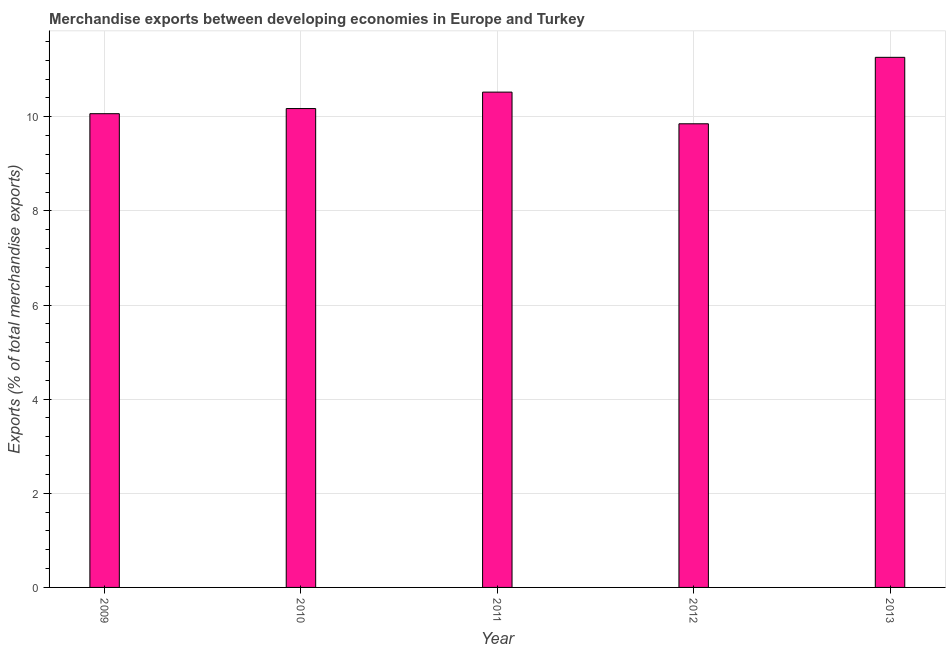Does the graph contain any zero values?
Your response must be concise. No. Does the graph contain grids?
Keep it short and to the point. Yes. What is the title of the graph?
Your answer should be compact. Merchandise exports between developing economies in Europe and Turkey. What is the label or title of the X-axis?
Provide a short and direct response. Year. What is the label or title of the Y-axis?
Your answer should be very brief. Exports (% of total merchandise exports). What is the merchandise exports in 2009?
Provide a short and direct response. 10.07. Across all years, what is the maximum merchandise exports?
Keep it short and to the point. 11.26. Across all years, what is the minimum merchandise exports?
Provide a short and direct response. 9.85. What is the sum of the merchandise exports?
Offer a terse response. 51.88. What is the difference between the merchandise exports in 2012 and 2013?
Provide a succinct answer. -1.41. What is the average merchandise exports per year?
Offer a very short reply. 10.38. What is the median merchandise exports?
Offer a very short reply. 10.17. In how many years, is the merchandise exports greater than 11.2 %?
Make the answer very short. 1. Do a majority of the years between 2011 and 2013 (inclusive) have merchandise exports greater than 10.4 %?
Your response must be concise. Yes. Is the merchandise exports in 2010 less than that in 2012?
Your response must be concise. No. Is the difference between the merchandise exports in 2010 and 2012 greater than the difference between any two years?
Make the answer very short. No. What is the difference between the highest and the second highest merchandise exports?
Your response must be concise. 0.74. What is the difference between the highest and the lowest merchandise exports?
Your response must be concise. 1.41. How many years are there in the graph?
Offer a very short reply. 5. Are the values on the major ticks of Y-axis written in scientific E-notation?
Offer a very short reply. No. What is the Exports (% of total merchandise exports) in 2009?
Ensure brevity in your answer.  10.07. What is the Exports (% of total merchandise exports) in 2010?
Provide a succinct answer. 10.17. What is the Exports (% of total merchandise exports) in 2011?
Offer a terse response. 10.52. What is the Exports (% of total merchandise exports) in 2012?
Provide a short and direct response. 9.85. What is the Exports (% of total merchandise exports) of 2013?
Ensure brevity in your answer.  11.26. What is the difference between the Exports (% of total merchandise exports) in 2009 and 2010?
Provide a succinct answer. -0.11. What is the difference between the Exports (% of total merchandise exports) in 2009 and 2011?
Your response must be concise. -0.46. What is the difference between the Exports (% of total merchandise exports) in 2009 and 2012?
Offer a very short reply. 0.21. What is the difference between the Exports (% of total merchandise exports) in 2009 and 2013?
Your answer should be compact. -1.2. What is the difference between the Exports (% of total merchandise exports) in 2010 and 2011?
Ensure brevity in your answer.  -0.35. What is the difference between the Exports (% of total merchandise exports) in 2010 and 2012?
Provide a succinct answer. 0.32. What is the difference between the Exports (% of total merchandise exports) in 2010 and 2013?
Your answer should be very brief. -1.09. What is the difference between the Exports (% of total merchandise exports) in 2011 and 2012?
Offer a terse response. 0.67. What is the difference between the Exports (% of total merchandise exports) in 2011 and 2013?
Offer a terse response. -0.74. What is the difference between the Exports (% of total merchandise exports) in 2012 and 2013?
Provide a short and direct response. -1.41. What is the ratio of the Exports (% of total merchandise exports) in 2009 to that in 2011?
Provide a succinct answer. 0.96. What is the ratio of the Exports (% of total merchandise exports) in 2009 to that in 2012?
Your answer should be compact. 1.02. What is the ratio of the Exports (% of total merchandise exports) in 2009 to that in 2013?
Keep it short and to the point. 0.89. What is the ratio of the Exports (% of total merchandise exports) in 2010 to that in 2012?
Give a very brief answer. 1.03. What is the ratio of the Exports (% of total merchandise exports) in 2010 to that in 2013?
Give a very brief answer. 0.9. What is the ratio of the Exports (% of total merchandise exports) in 2011 to that in 2012?
Provide a succinct answer. 1.07. What is the ratio of the Exports (% of total merchandise exports) in 2011 to that in 2013?
Provide a succinct answer. 0.93. 